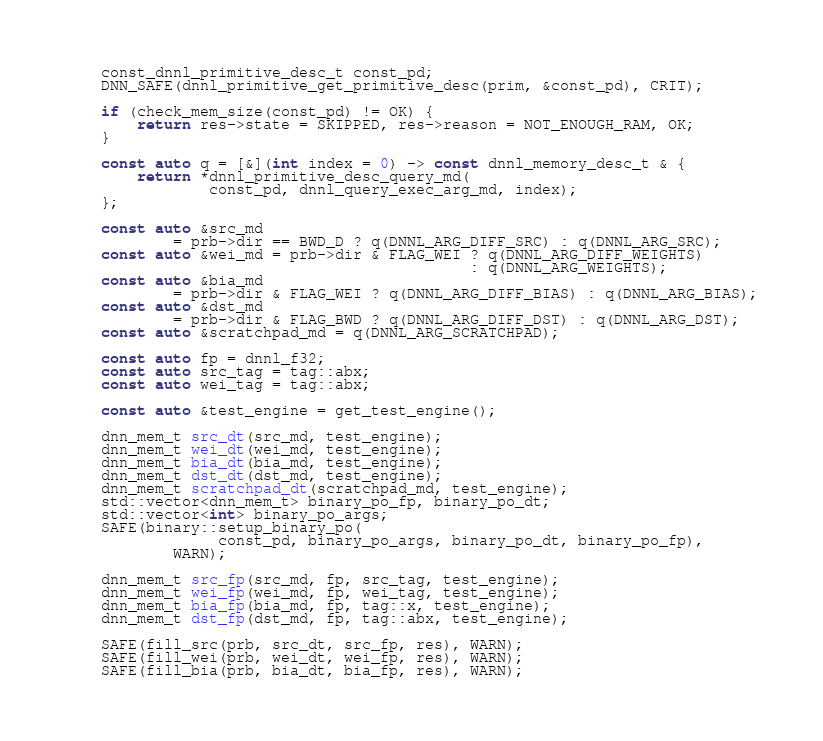Convert code to text. <code><loc_0><loc_0><loc_500><loc_500><_C++_>
    const_dnnl_primitive_desc_t const_pd;
    DNN_SAFE(dnnl_primitive_get_primitive_desc(prim, &const_pd), CRIT);

    if (check_mem_size(const_pd) != OK) {
        return res->state = SKIPPED, res->reason = NOT_ENOUGH_RAM, OK;
    }

    const auto q = [&](int index = 0) -> const dnnl_memory_desc_t & {
        return *dnnl_primitive_desc_query_md(
                const_pd, dnnl_query_exec_arg_md, index);
    };

    const auto &src_md
            = prb->dir == BWD_D ? q(DNNL_ARG_DIFF_SRC) : q(DNNL_ARG_SRC);
    const auto &wei_md = prb->dir & FLAG_WEI ? q(DNNL_ARG_DIFF_WEIGHTS)
                                             : q(DNNL_ARG_WEIGHTS);
    const auto &bia_md
            = prb->dir & FLAG_WEI ? q(DNNL_ARG_DIFF_BIAS) : q(DNNL_ARG_BIAS);
    const auto &dst_md
            = prb->dir & FLAG_BWD ? q(DNNL_ARG_DIFF_DST) : q(DNNL_ARG_DST);
    const auto &scratchpad_md = q(DNNL_ARG_SCRATCHPAD);

    const auto fp = dnnl_f32;
    const auto src_tag = tag::abx;
    const auto wei_tag = tag::abx;

    const auto &test_engine = get_test_engine();

    dnn_mem_t src_dt(src_md, test_engine);
    dnn_mem_t wei_dt(wei_md, test_engine);
    dnn_mem_t bia_dt(bia_md, test_engine);
    dnn_mem_t dst_dt(dst_md, test_engine);
    dnn_mem_t scratchpad_dt(scratchpad_md, test_engine);
    std::vector<dnn_mem_t> binary_po_fp, binary_po_dt;
    std::vector<int> binary_po_args;
    SAFE(binary::setup_binary_po(
                 const_pd, binary_po_args, binary_po_dt, binary_po_fp),
            WARN);

    dnn_mem_t src_fp(src_md, fp, src_tag, test_engine);
    dnn_mem_t wei_fp(wei_md, fp, wei_tag, test_engine);
    dnn_mem_t bia_fp(bia_md, fp, tag::x, test_engine);
    dnn_mem_t dst_fp(dst_md, fp, tag::abx, test_engine);

    SAFE(fill_src(prb, src_dt, src_fp, res), WARN);
    SAFE(fill_wei(prb, wei_dt, wei_fp, res), WARN);
    SAFE(fill_bia(prb, bia_dt, bia_fp, res), WARN);</code> 